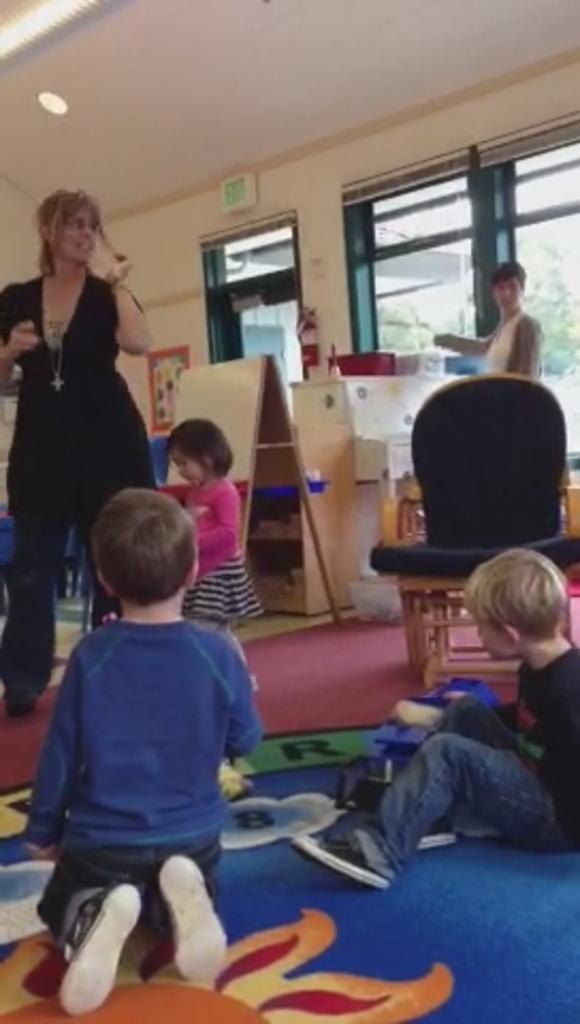Please provide a concise description of this image. As we can see in the image there is a wall, windows, few people standing here and there. On the right side there is a chair. 